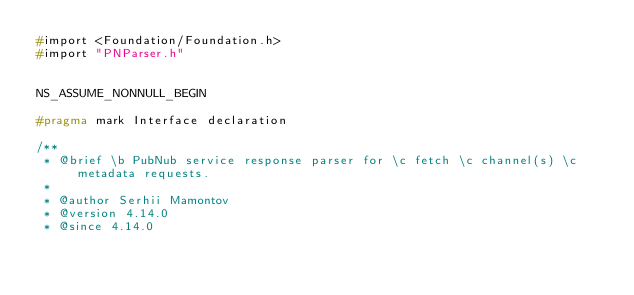Convert code to text. <code><loc_0><loc_0><loc_500><loc_500><_C_>#import <Foundation/Foundation.h>
#import "PNParser.h"


NS_ASSUME_NONNULL_BEGIN

#pragma mark Interface declaration

/**
 * @brief \b PubNub service response parser for \c fetch \c channel(s) \c metadata requests.
 *
 * @author Serhii Mamontov
 * @version 4.14.0
 * @since 4.14.0</code> 